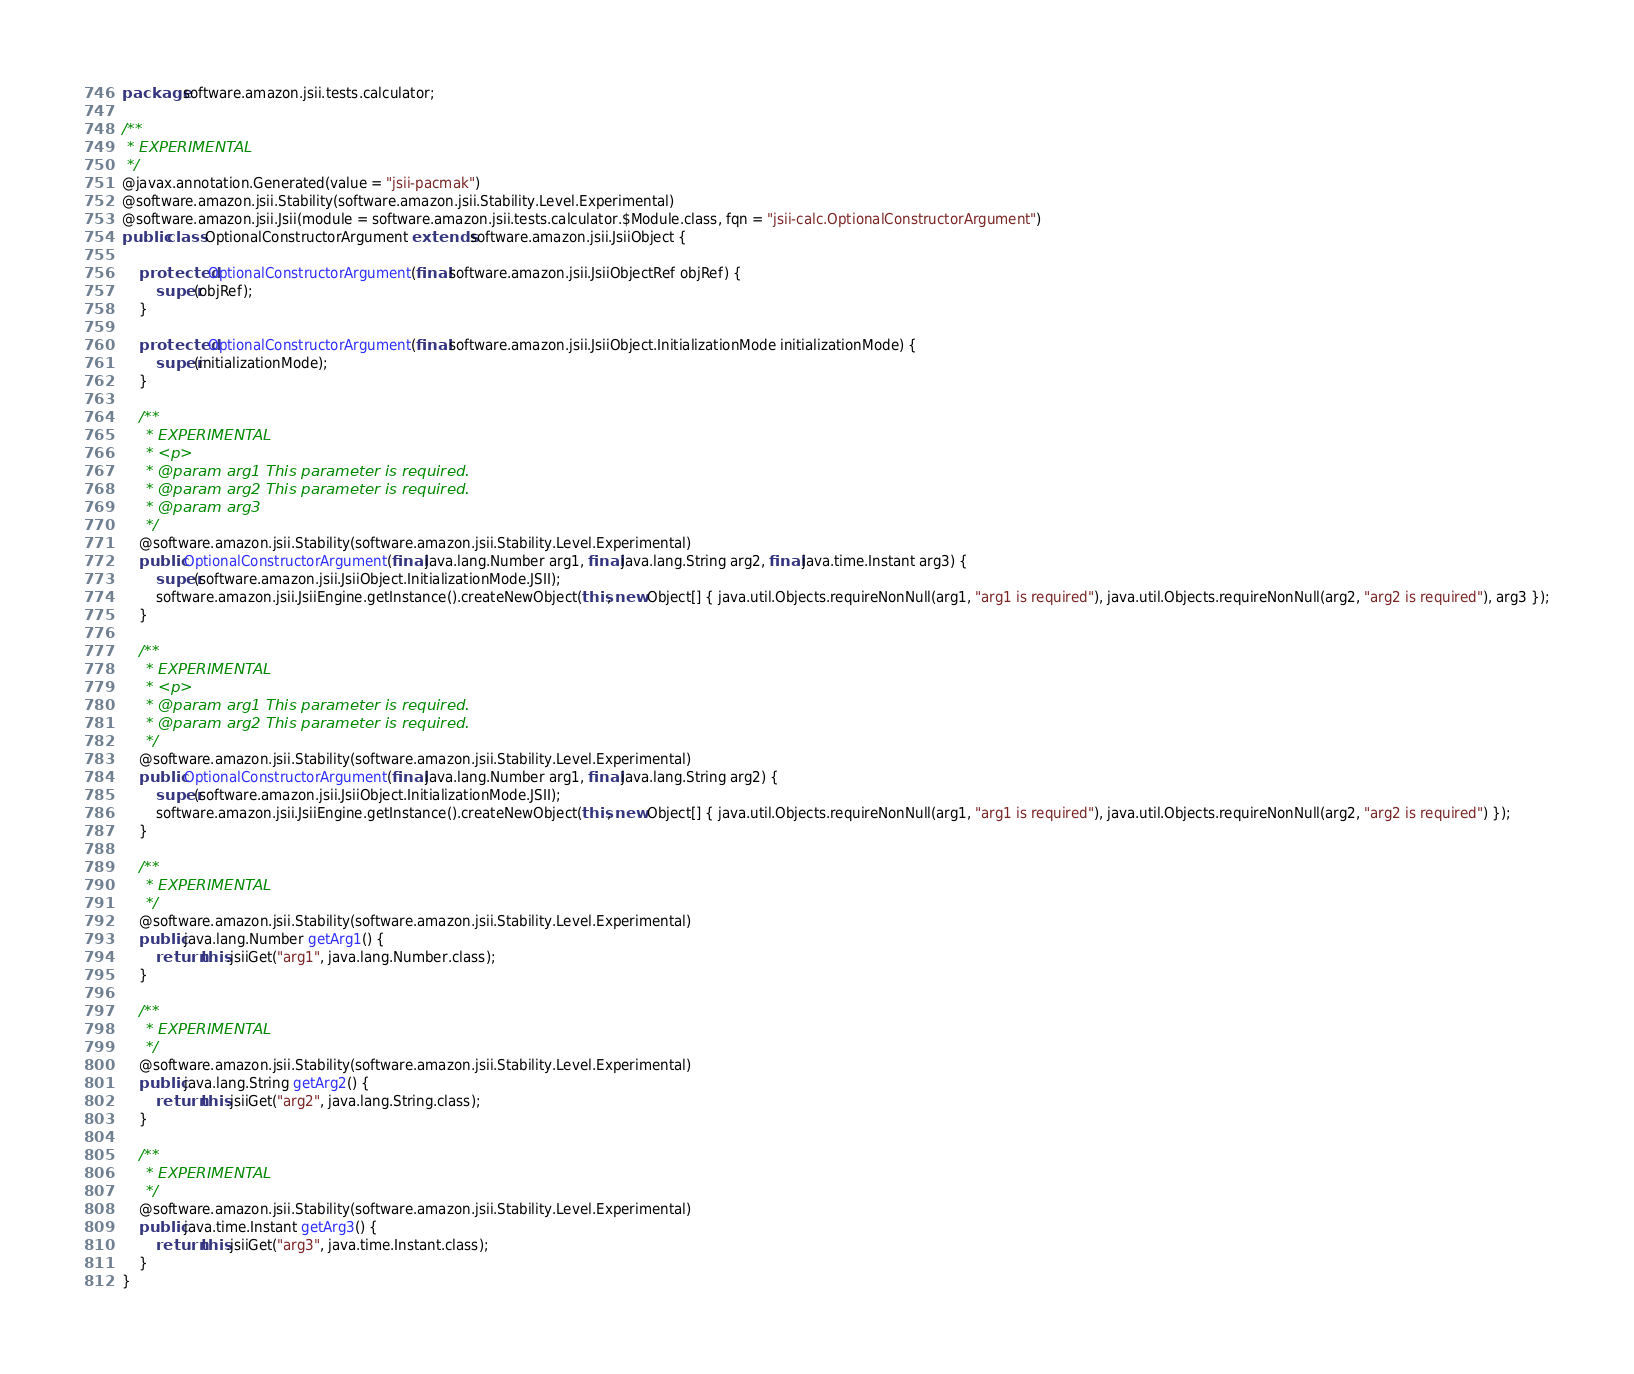Convert code to text. <code><loc_0><loc_0><loc_500><loc_500><_Java_>package software.amazon.jsii.tests.calculator;

/**
 * EXPERIMENTAL
 */
@javax.annotation.Generated(value = "jsii-pacmak")
@software.amazon.jsii.Stability(software.amazon.jsii.Stability.Level.Experimental)
@software.amazon.jsii.Jsii(module = software.amazon.jsii.tests.calculator.$Module.class, fqn = "jsii-calc.OptionalConstructorArgument")
public class OptionalConstructorArgument extends software.amazon.jsii.JsiiObject {

    protected OptionalConstructorArgument(final software.amazon.jsii.JsiiObjectRef objRef) {
        super(objRef);
    }

    protected OptionalConstructorArgument(final software.amazon.jsii.JsiiObject.InitializationMode initializationMode) {
        super(initializationMode);
    }

    /**
     * EXPERIMENTAL
     * <p>
     * @param arg1 This parameter is required.
     * @param arg2 This parameter is required.
     * @param arg3
     */
    @software.amazon.jsii.Stability(software.amazon.jsii.Stability.Level.Experimental)
    public OptionalConstructorArgument(final java.lang.Number arg1, final java.lang.String arg2, final java.time.Instant arg3) {
        super(software.amazon.jsii.JsiiObject.InitializationMode.JSII);
        software.amazon.jsii.JsiiEngine.getInstance().createNewObject(this, new Object[] { java.util.Objects.requireNonNull(arg1, "arg1 is required"), java.util.Objects.requireNonNull(arg2, "arg2 is required"), arg3 });
    }

    /**
     * EXPERIMENTAL
     * <p>
     * @param arg1 This parameter is required.
     * @param arg2 This parameter is required.
     */
    @software.amazon.jsii.Stability(software.amazon.jsii.Stability.Level.Experimental)
    public OptionalConstructorArgument(final java.lang.Number arg1, final java.lang.String arg2) {
        super(software.amazon.jsii.JsiiObject.InitializationMode.JSII);
        software.amazon.jsii.JsiiEngine.getInstance().createNewObject(this, new Object[] { java.util.Objects.requireNonNull(arg1, "arg1 is required"), java.util.Objects.requireNonNull(arg2, "arg2 is required") });
    }

    /**
     * EXPERIMENTAL
     */
    @software.amazon.jsii.Stability(software.amazon.jsii.Stability.Level.Experimental)
    public java.lang.Number getArg1() {
        return this.jsiiGet("arg1", java.lang.Number.class);
    }

    /**
     * EXPERIMENTAL
     */
    @software.amazon.jsii.Stability(software.amazon.jsii.Stability.Level.Experimental)
    public java.lang.String getArg2() {
        return this.jsiiGet("arg2", java.lang.String.class);
    }

    /**
     * EXPERIMENTAL
     */
    @software.amazon.jsii.Stability(software.amazon.jsii.Stability.Level.Experimental)
    public java.time.Instant getArg3() {
        return this.jsiiGet("arg3", java.time.Instant.class);
    }
}
</code> 